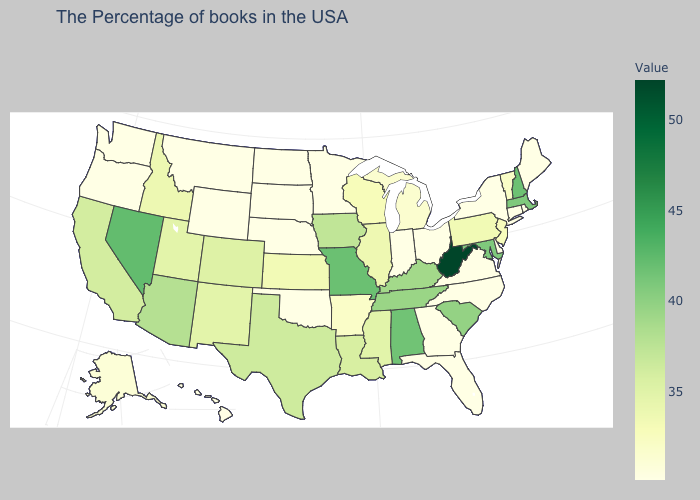Which states have the highest value in the USA?
Keep it brief. West Virginia. Does the map have missing data?
Quick response, please. No. Does West Virginia have the highest value in the USA?
Keep it brief. Yes. Which states have the highest value in the USA?
Be succinct. West Virginia. Among the states that border Massachusetts , does New Hampshire have the highest value?
Keep it brief. Yes. 